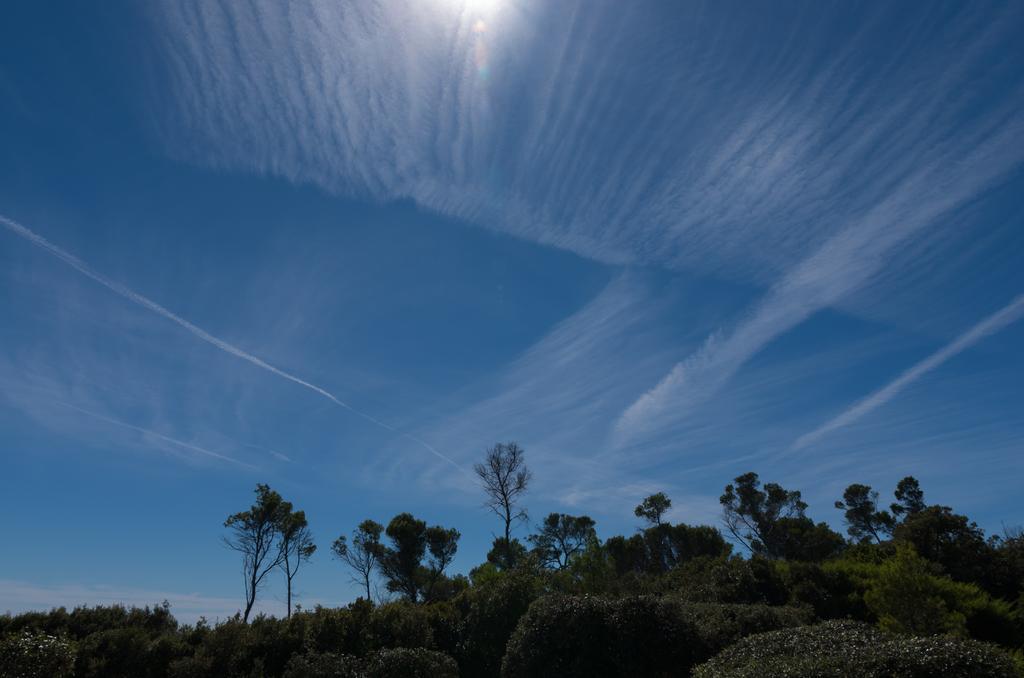How would you summarize this image in a sentence or two? In this picture we can see a few bushes at the bottom of the picture. We can see a few plants and trees in the background. Sky is blue in color. 